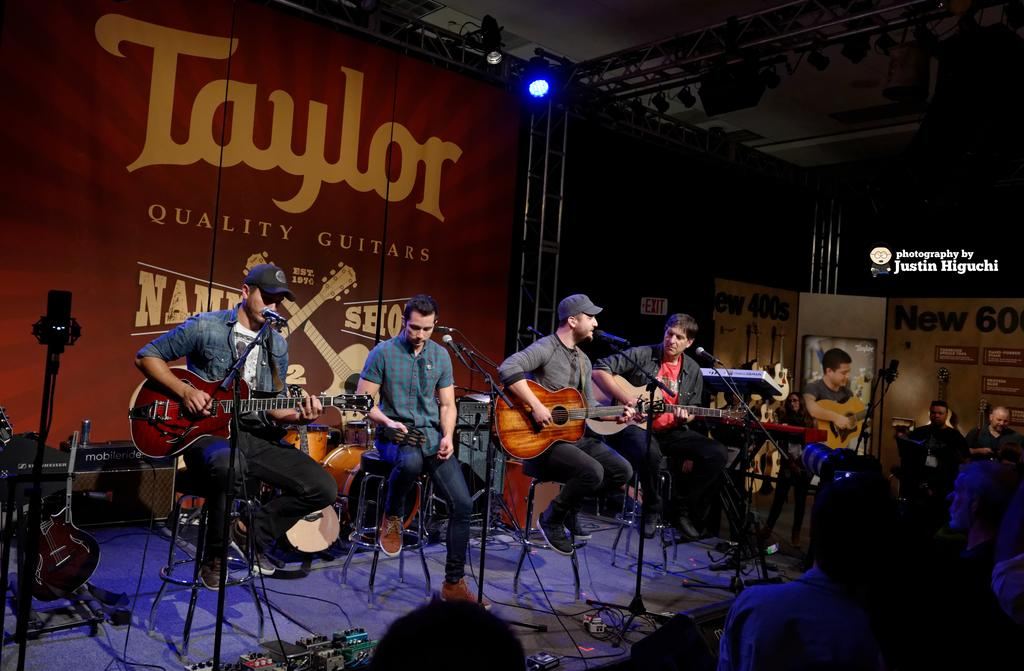Who or what is present in the image? There are people in the image. What are the people doing in the image? The people are sitting on chairs. What objects are the people holding in the image? The people are holding guitars in their hands. What type of horses can be seen in the image? There are no horses present in the image; it features people sitting on chairs and holding guitars. How many oranges are visible in the image? There are no oranges present in the image. 